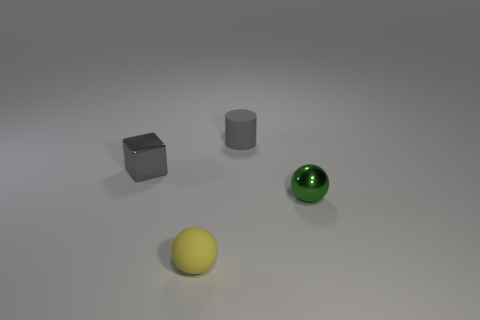Add 2 big yellow objects. How many objects exist? 6 Subtract all brown balls. Subtract all green blocks. How many balls are left? 2 Subtract all cylinders. How many objects are left? 3 Add 2 tiny blue balls. How many tiny blue balls exist? 2 Subtract 0 gray spheres. How many objects are left? 4 Subtract all tiny cyan matte cubes. Subtract all small green metal balls. How many objects are left? 3 Add 3 small shiny objects. How many small shiny objects are left? 5 